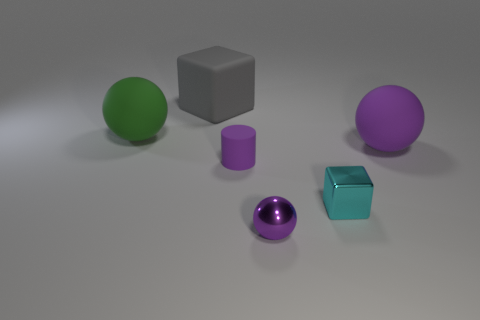What number of green balls are the same material as the tiny cyan block?
Your response must be concise. 0. What shape is the tiny rubber object that is the same color as the tiny sphere?
Offer a very short reply. Cylinder. What is the shape of the purple matte thing that is the same size as the cyan metal object?
Keep it short and to the point. Cylinder. There is a small thing that is the same color as the cylinder; what material is it?
Make the answer very short. Metal. There is a cylinder; are there any purple things left of it?
Provide a short and direct response. No. Is there a tiny yellow rubber thing that has the same shape as the green thing?
Your answer should be compact. No. Does the purple rubber thing that is on the left side of the small metal cube have the same shape as the large matte thing in front of the big green object?
Provide a short and direct response. No. Is there a purple thing that has the same size as the cyan shiny object?
Make the answer very short. Yes. Are there an equal number of purple shiny spheres behind the gray rubber cube and matte spheres that are left of the large purple rubber ball?
Give a very brief answer. No. Do the small purple thing that is behind the tiny cyan shiny cube and the large thing that is to the right of the tiny cyan object have the same material?
Provide a short and direct response. Yes. 